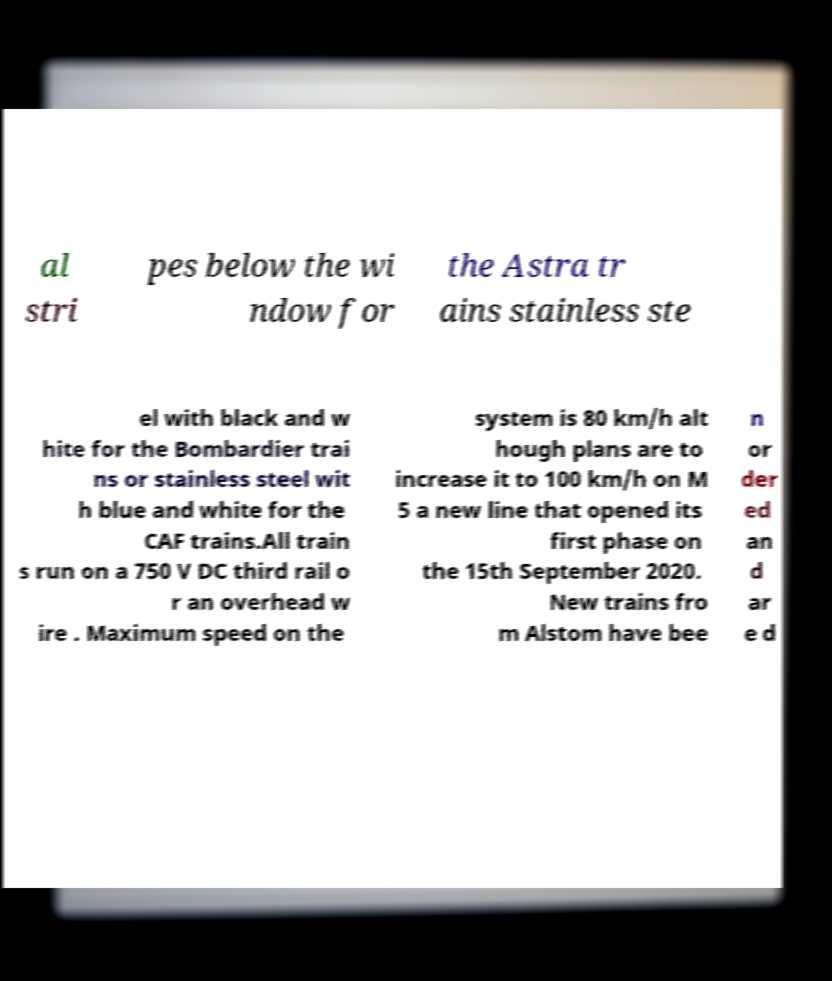Can you read and provide the text displayed in the image?This photo seems to have some interesting text. Can you extract and type it out for me? al stri pes below the wi ndow for the Astra tr ains stainless ste el with black and w hite for the Bombardier trai ns or stainless steel wit h blue and white for the CAF trains.All train s run on a 750 V DC third rail o r an overhead w ire . Maximum speed on the system is 80 km/h alt hough plans are to increase it to 100 km/h on M 5 a new line that opened its first phase on the 15th September 2020. New trains fro m Alstom have bee n or der ed an d ar e d 